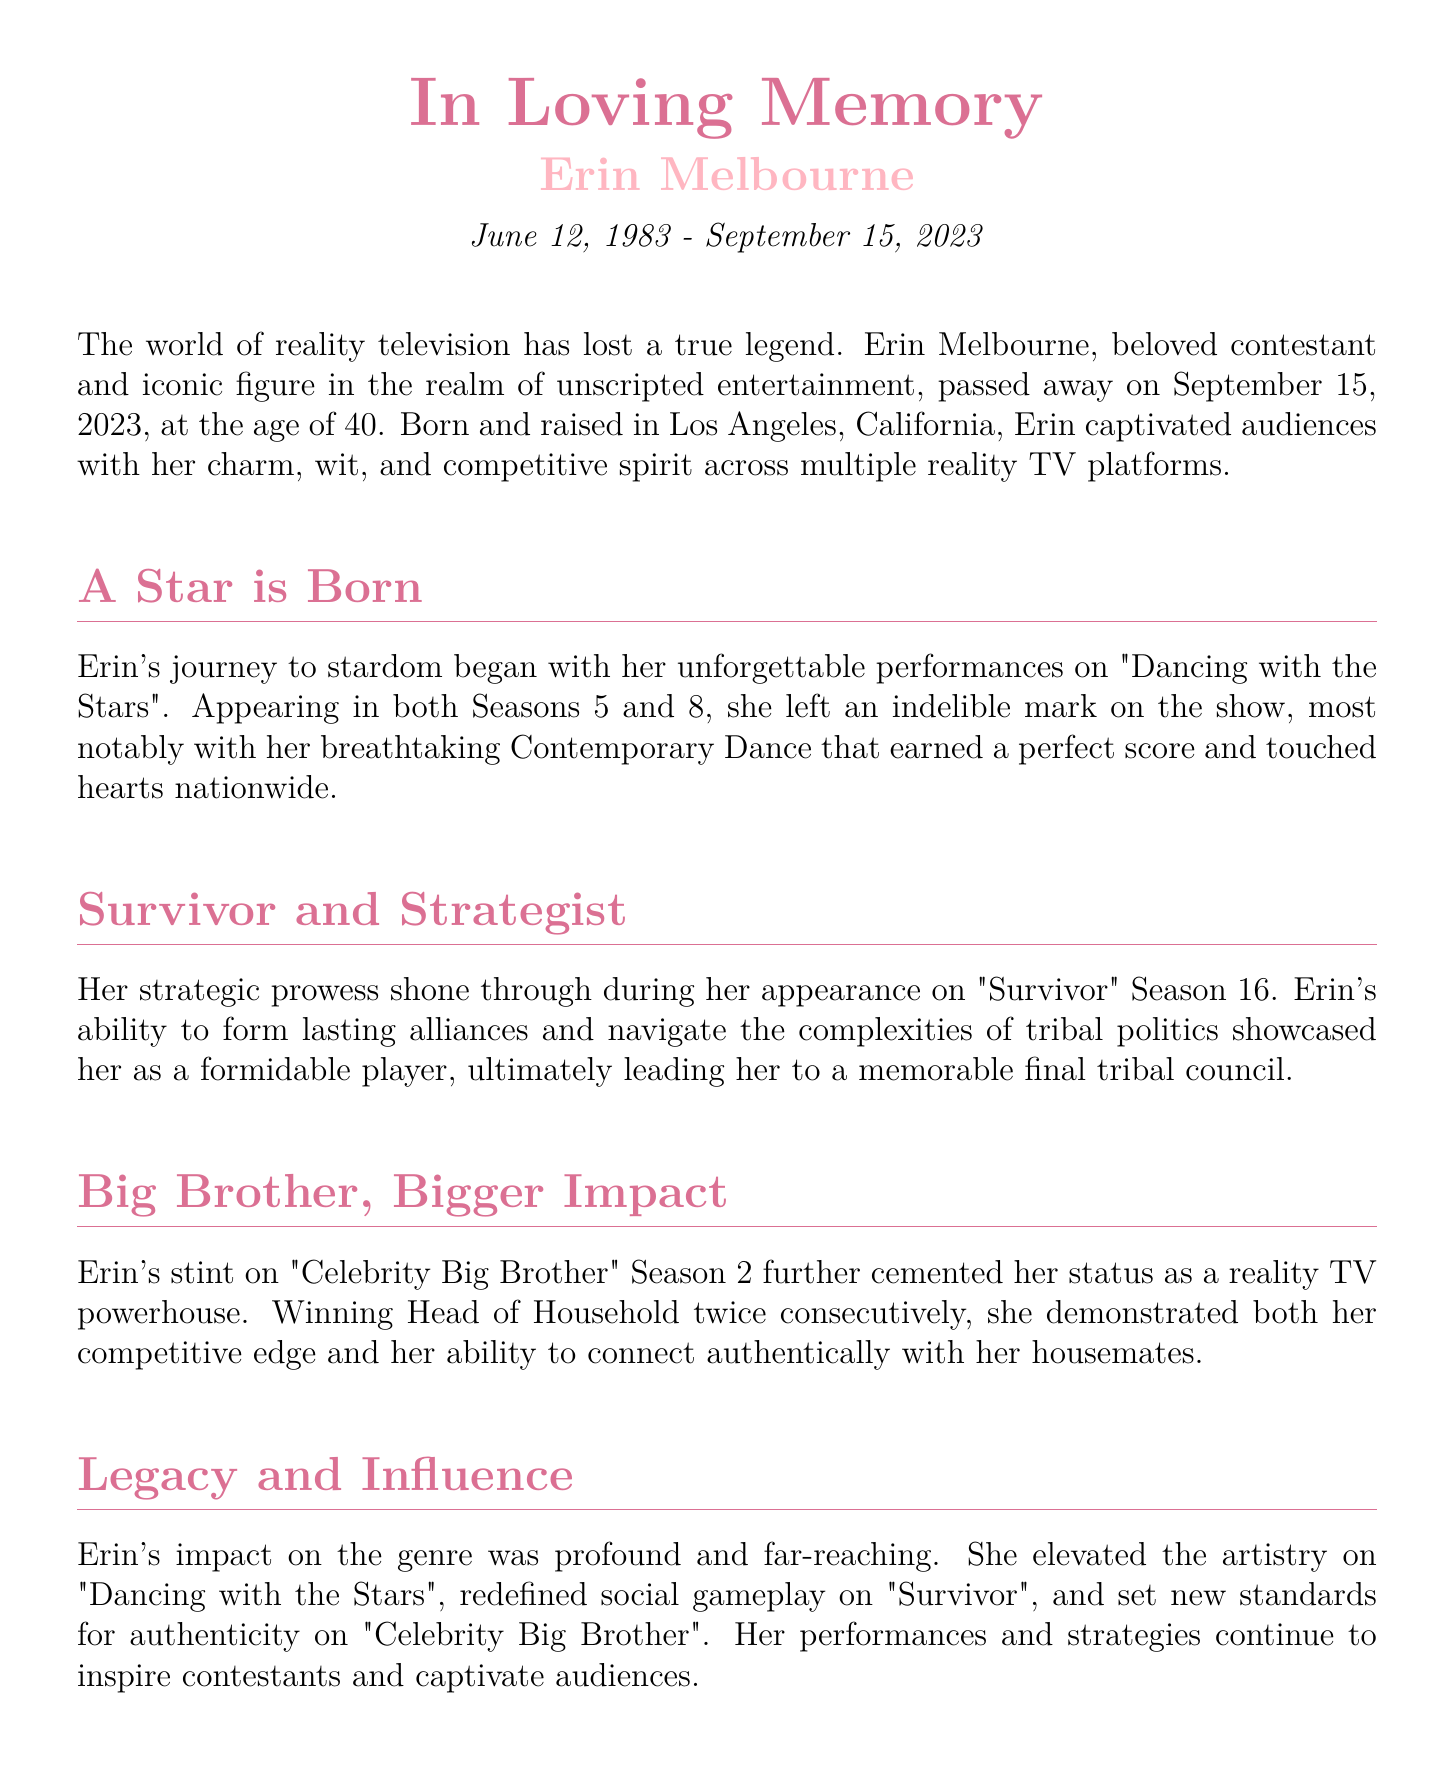What date did Erin Melbourne pass away? The document states that Erin Melbourne passed away on September 15, 2023.
Answer: September 15, 2023 How many children did Erin Melbourne have? The obituary mentions that Erin Melbourne is survived by two children named Liam and Emily.
Answer: Two On which reality show did Erin achieve a perfect score with a Contemporary Dance? Erin earned a perfect score with her Contemporary Dance on "Dancing with the Stars".
Answer: Dancing with the Stars Who described Erin as "more than just a fierce competitor"? Max Johnson, a fellow contestant, described Erin in that way.
Answer: Max Johnson What was one of Erin's philanthropic commitments? The document mentions that Erin was committed to supporting mental health initiatives.
Answer: Mental health initiatives Which season of "Survivor" did Erin appear in? Erin appeared in "Survivor" Season 16.
Answer: Season 16 What aspect of reality TV did Erin redefine according to the obituary? Erin redefined social gameplay on "Survivor".
Answer: Social gameplay Which reality show did Erin compete on twice? Erin competed on "Dancing with the Stars" in Seasons 5 and 8.
Answer: Dancing with the Stars 